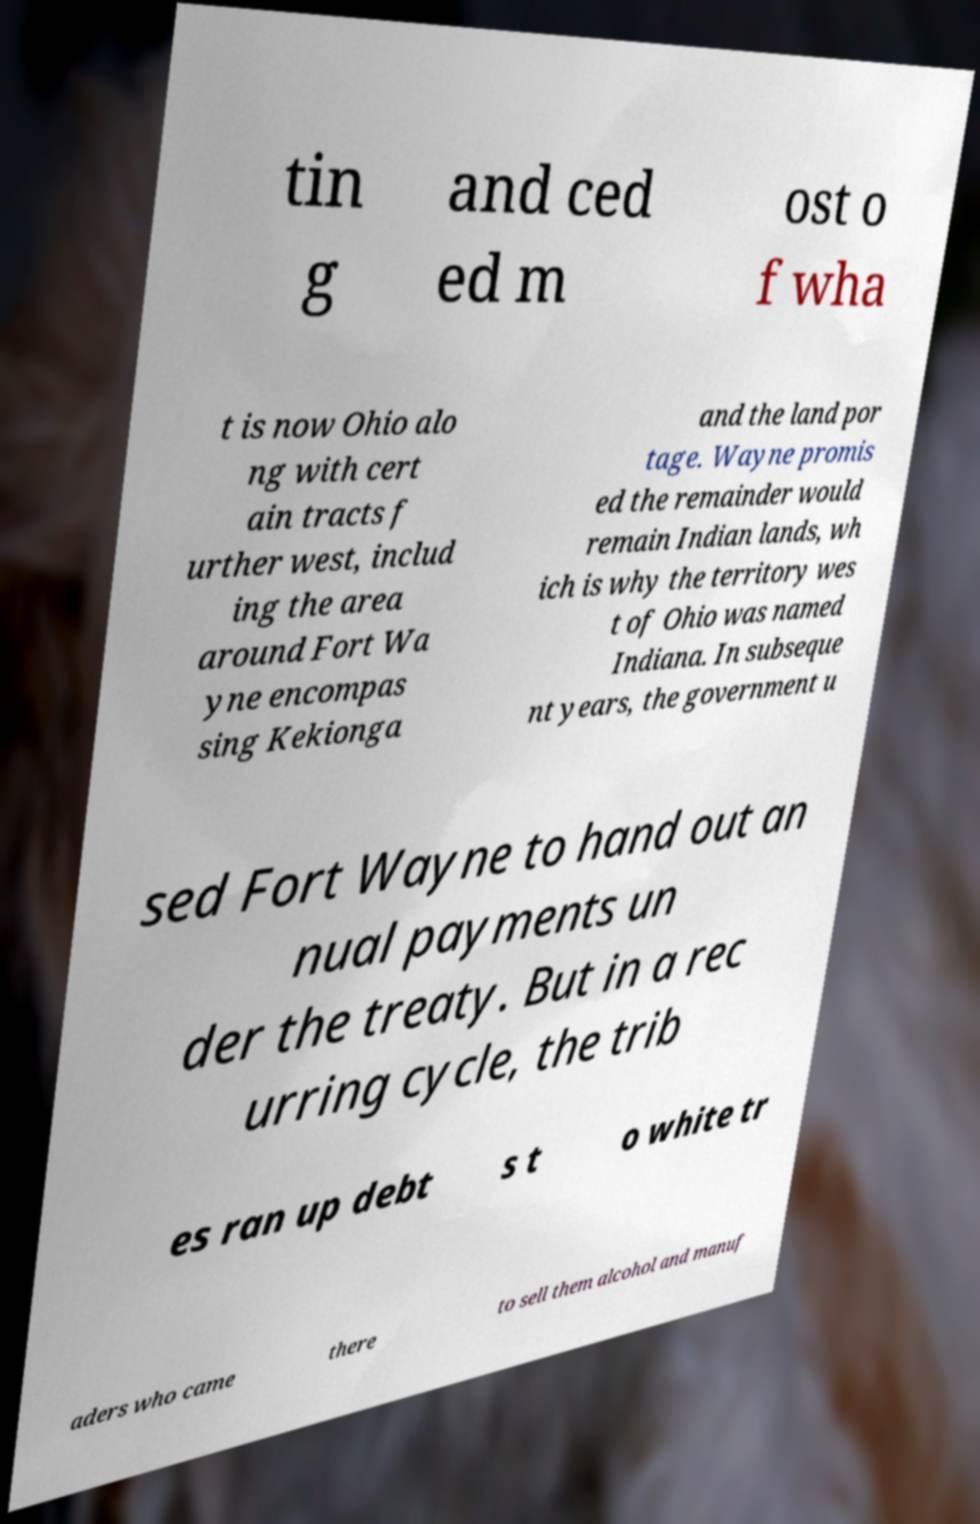There's text embedded in this image that I need extracted. Can you transcribe it verbatim? tin g and ced ed m ost o f wha t is now Ohio alo ng with cert ain tracts f urther west, includ ing the area around Fort Wa yne encompas sing Kekionga and the land por tage. Wayne promis ed the remainder would remain Indian lands, wh ich is why the territory wes t of Ohio was named Indiana. In subseque nt years, the government u sed Fort Wayne to hand out an nual payments un der the treaty. But in a rec urring cycle, the trib es ran up debt s t o white tr aders who came there to sell them alcohol and manuf 